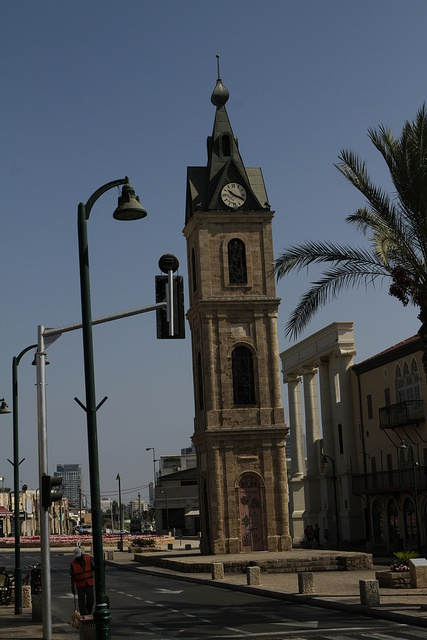Describe the objects in this image and their specific colors. I can see traffic light in blue, black, gray, and darkgray tones, people in blue, black, maroon, and gray tones, traffic light in blue, black, gray, and tan tones, clock in blue, gray, and black tones, and people in black and blue tones in this image. 